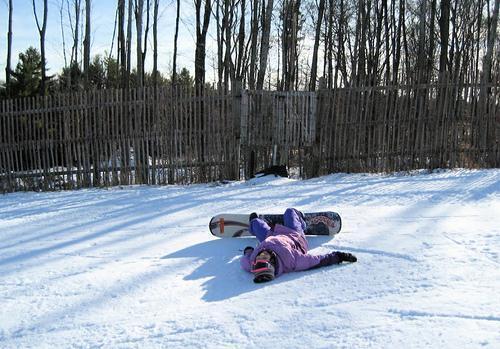How many people are there?
Give a very brief answer. 1. 